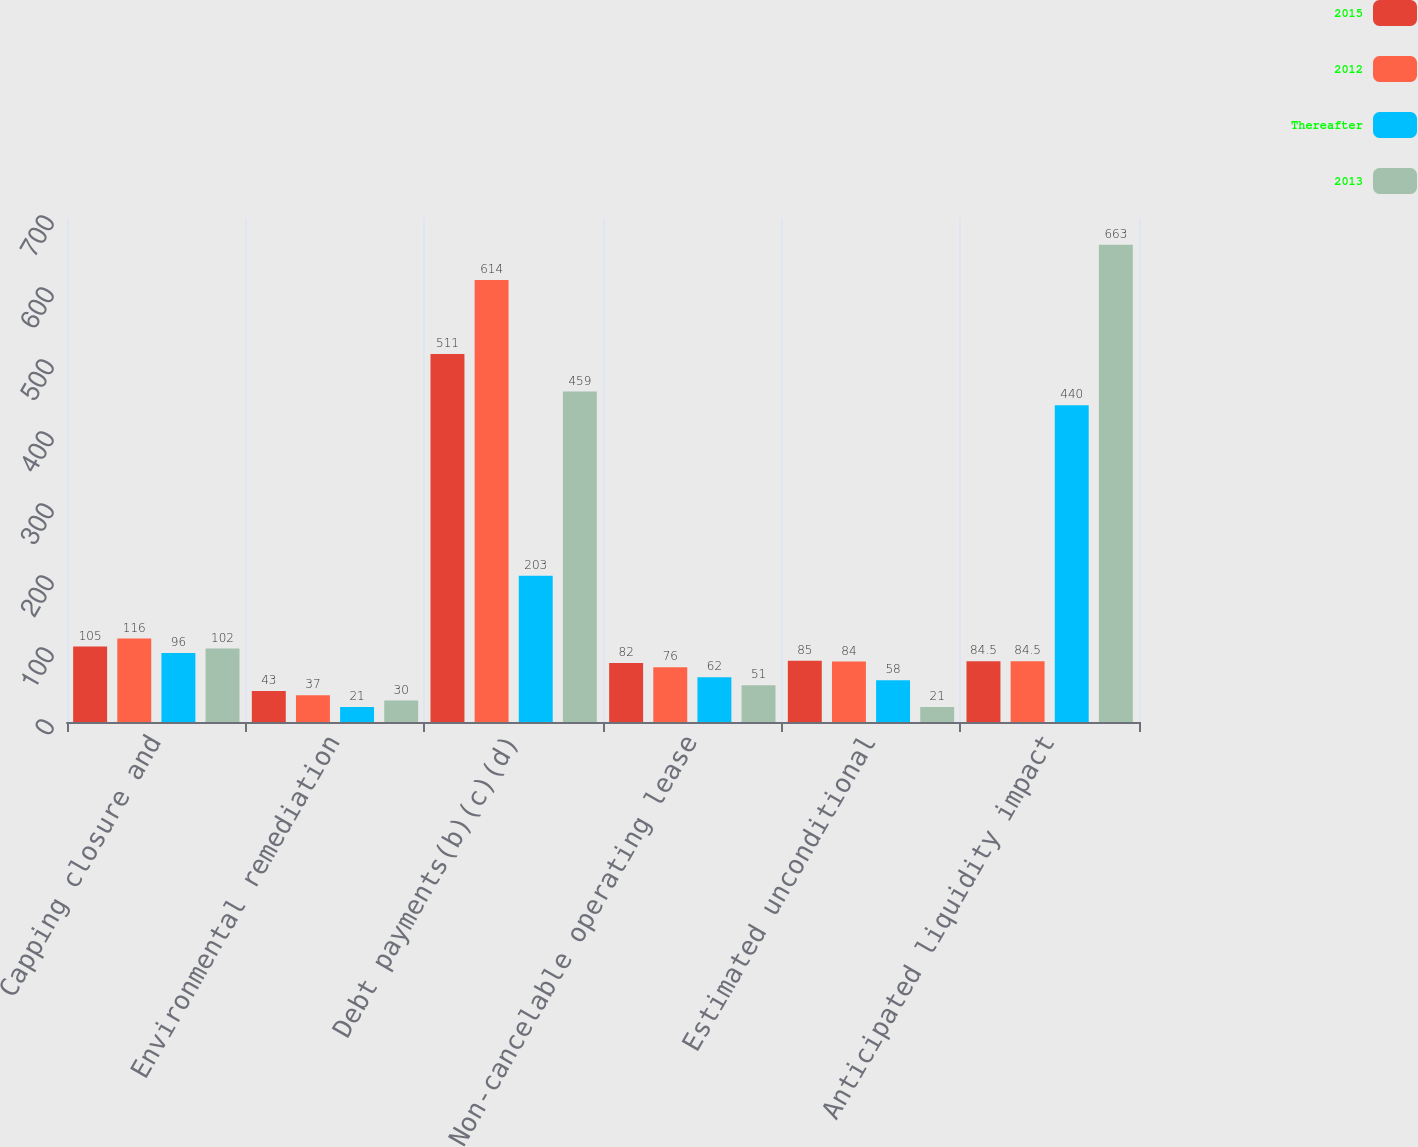Convert chart to OTSL. <chart><loc_0><loc_0><loc_500><loc_500><stacked_bar_chart><ecel><fcel>Capping closure and<fcel>Environmental remediation<fcel>Debt payments(b)(c)(d)<fcel>Non-cancelable operating lease<fcel>Estimated unconditional<fcel>Anticipated liquidity impact<nl><fcel>2015<fcel>105<fcel>43<fcel>511<fcel>82<fcel>85<fcel>84.5<nl><fcel>2012<fcel>116<fcel>37<fcel>614<fcel>76<fcel>84<fcel>84.5<nl><fcel>Thereafter<fcel>96<fcel>21<fcel>203<fcel>62<fcel>58<fcel>440<nl><fcel>2013<fcel>102<fcel>30<fcel>459<fcel>51<fcel>21<fcel>663<nl></chart> 